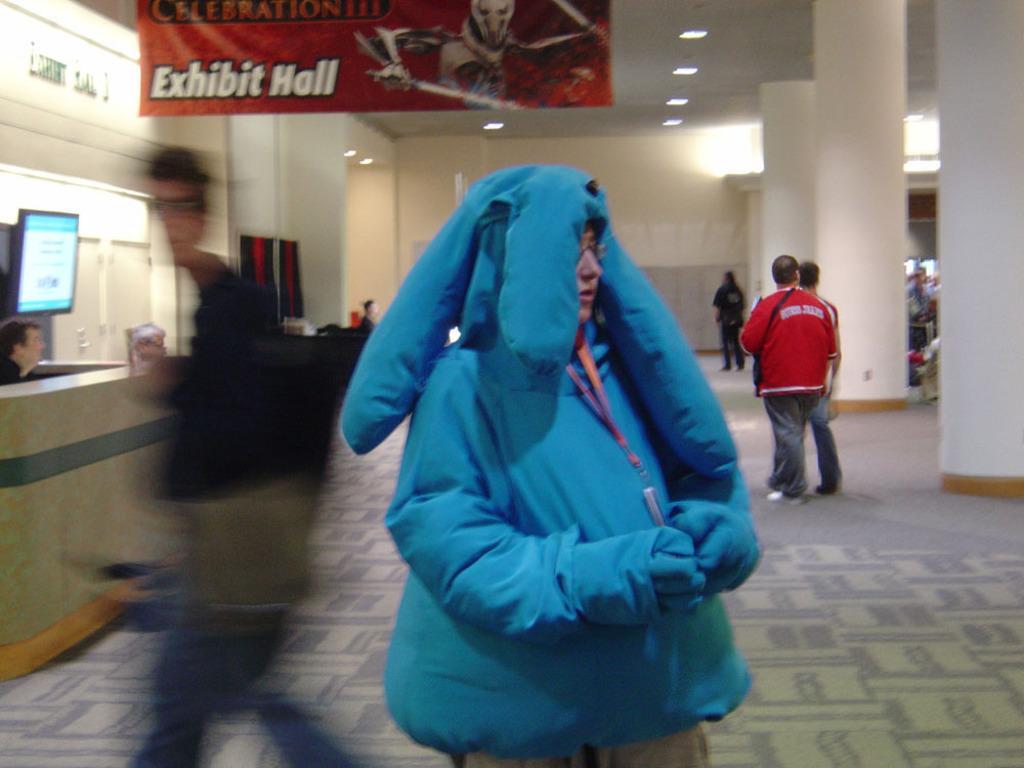Please provide a concise description of this image. In this image in the foreground, a woman wearing a blue color jacket, on the left side there is a man visible in front of desk beside him, there is a screen attached to the wall and in front of desk I can see a person walking on the floor, in the middle there are few people visible and on the left side there are beams, people, at the top there is a banner attached to the roof. 